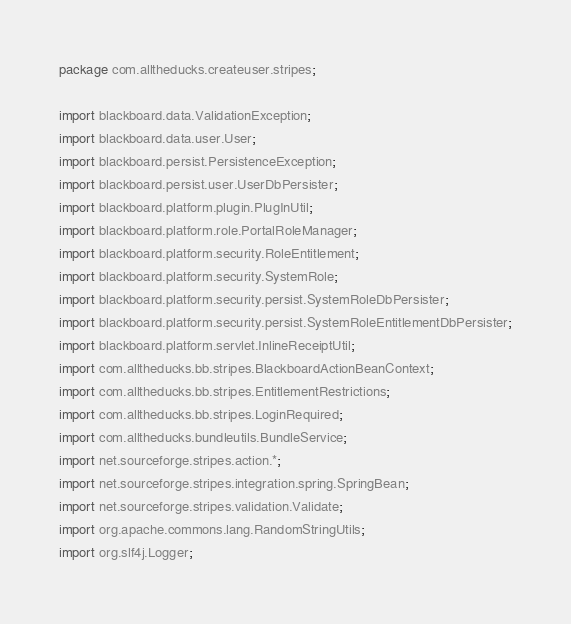Convert code to text. <code><loc_0><loc_0><loc_500><loc_500><_Java_>package com.alltheducks.createuser.stripes;

import blackboard.data.ValidationException;
import blackboard.data.user.User;
import blackboard.persist.PersistenceException;
import blackboard.persist.user.UserDbPersister;
import blackboard.platform.plugin.PlugInUtil;
import blackboard.platform.role.PortalRoleManager;
import blackboard.platform.security.RoleEntitlement;
import blackboard.platform.security.SystemRole;
import blackboard.platform.security.persist.SystemRoleDbPersister;
import blackboard.platform.security.persist.SystemRoleEntitlementDbPersister;
import blackboard.platform.servlet.InlineReceiptUtil;
import com.alltheducks.bb.stripes.BlackboardActionBeanContext;
import com.alltheducks.bb.stripes.EntitlementRestrictions;
import com.alltheducks.bb.stripes.LoginRequired;
import com.alltheducks.bundleutils.BundleService;
import net.sourceforge.stripes.action.*;
import net.sourceforge.stripes.integration.spring.SpringBean;
import net.sourceforge.stripes.validation.Validate;
import org.apache.commons.lang.RandomStringUtils;
import org.slf4j.Logger;</code> 